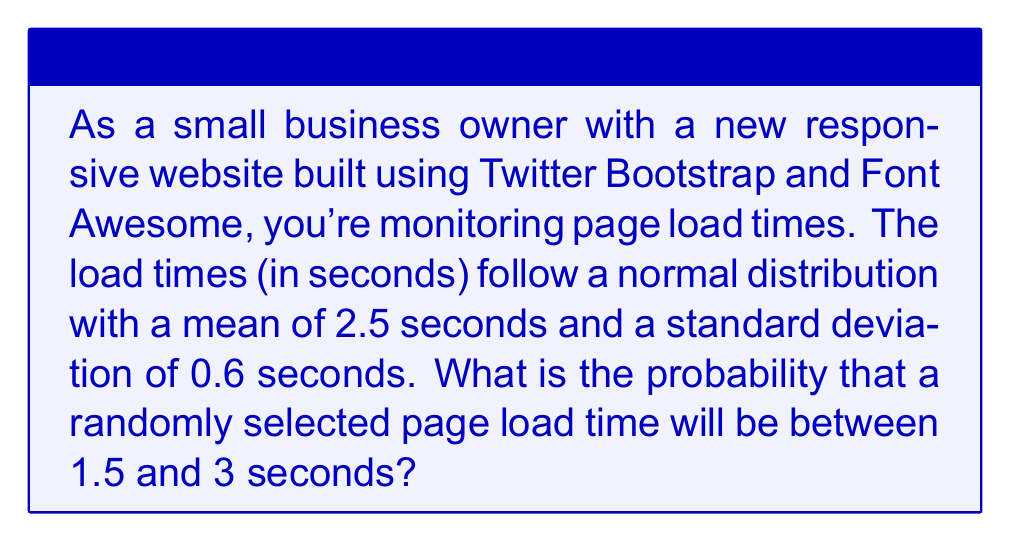Show me your answer to this math problem. To solve this problem, we need to use the properties of the normal distribution and the concept of z-scores. Let's approach this step-by-step:

1) We're given that the page load times follow a normal distribution with:
   $\mu = 2.5$ seconds (mean)
   $\sigma = 0.6$ seconds (standard deviation)

2) We want to find $P(1.5 < X < 3)$, where $X$ is the page load time.

3) To use the standard normal distribution table, we need to convert these values to z-scores:

   For 1.5 seconds: $z_1 = \frac{1.5 - 2.5}{0.6} = -1.67$
   For 3 seconds: $z_2 = \frac{3 - 2.5}{0.6} = 0.83$

4) Now we need to find $P(-1.67 < Z < 0.83)$, where $Z$ is the standard normal variable.

5) This probability can be calculated as:
   $P(-1.67 < Z < 0.83) = P(Z < 0.83) - P(Z < -1.67)$

6) Using a standard normal distribution table or calculator:
   $P(Z < 0.83) \approx 0.7967$
   $P(Z < -1.67) \approx 0.0475$

7) Therefore:
   $P(-1.67 < Z < 0.83) = 0.7967 - 0.0475 = 0.7492$

Thus, the probability that a randomly selected page load time will be between 1.5 and 3 seconds is approximately 0.7492 or 74.92%.
Answer: 0.7492 or 74.92% 